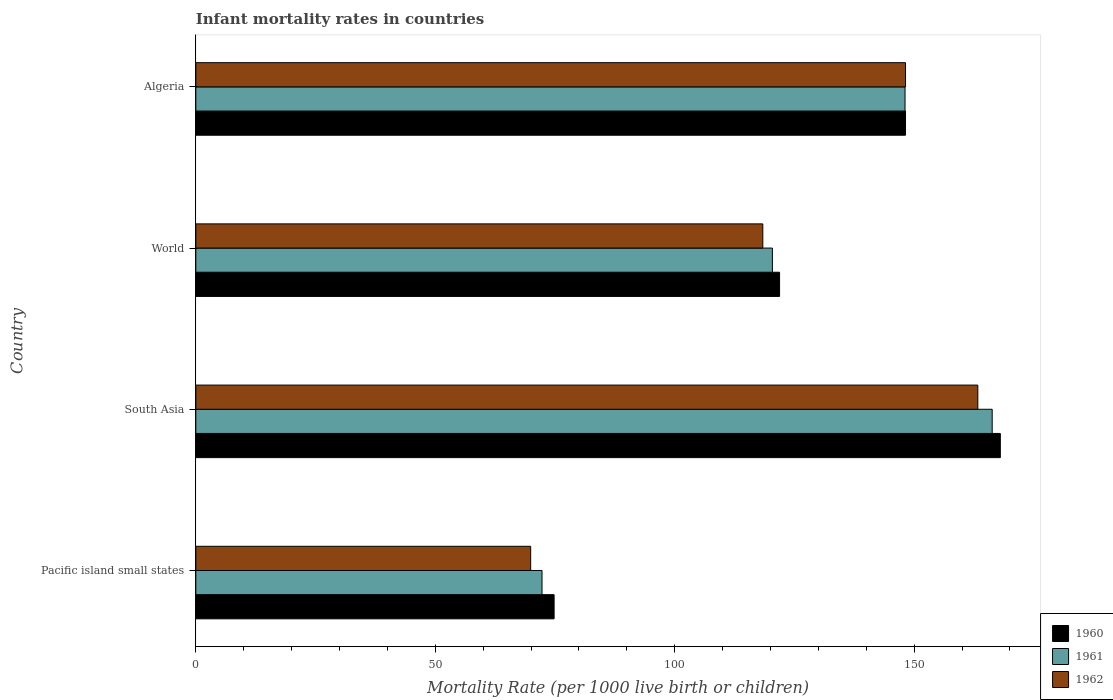How many bars are there on the 3rd tick from the top?
Provide a succinct answer. 3. What is the label of the 2nd group of bars from the top?
Make the answer very short. World. What is the infant mortality rate in 1962 in Pacific island small states?
Your answer should be compact. 69.93. Across all countries, what is the maximum infant mortality rate in 1960?
Keep it short and to the point. 168. Across all countries, what is the minimum infant mortality rate in 1962?
Make the answer very short. 69.93. In which country was the infant mortality rate in 1962 maximum?
Offer a very short reply. South Asia. In which country was the infant mortality rate in 1962 minimum?
Keep it short and to the point. Pacific island small states. What is the total infant mortality rate in 1961 in the graph?
Your answer should be very brief. 507.09. What is the difference between the infant mortality rate in 1960 in Algeria and that in World?
Provide a succinct answer. 26.3. What is the difference between the infant mortality rate in 1961 in Algeria and the infant mortality rate in 1960 in Pacific island small states?
Offer a very short reply. 73.28. What is the average infant mortality rate in 1961 per country?
Provide a short and direct response. 126.77. What is the difference between the infant mortality rate in 1960 and infant mortality rate in 1961 in Algeria?
Keep it short and to the point. 0.1. What is the ratio of the infant mortality rate in 1961 in Algeria to that in World?
Offer a terse response. 1.23. What is the difference between the highest and the second highest infant mortality rate in 1960?
Provide a short and direct response. 19.8. What is the difference between the highest and the lowest infant mortality rate in 1961?
Offer a very short reply. 94.01. In how many countries, is the infant mortality rate in 1961 greater than the average infant mortality rate in 1961 taken over all countries?
Your response must be concise. 2. Is the sum of the infant mortality rate in 1961 in Algeria and Pacific island small states greater than the maximum infant mortality rate in 1960 across all countries?
Keep it short and to the point. Yes. What does the 2nd bar from the top in Pacific island small states represents?
Make the answer very short. 1961. What does the 1st bar from the bottom in South Asia represents?
Keep it short and to the point. 1960. How many bars are there?
Provide a short and direct response. 12. Are all the bars in the graph horizontal?
Give a very brief answer. Yes. Are the values on the major ticks of X-axis written in scientific E-notation?
Your answer should be very brief. No. Does the graph contain any zero values?
Your answer should be very brief. No. How are the legend labels stacked?
Give a very brief answer. Vertical. What is the title of the graph?
Your answer should be compact. Infant mortality rates in countries. What is the label or title of the X-axis?
Ensure brevity in your answer.  Mortality Rate (per 1000 live birth or children). What is the label or title of the Y-axis?
Keep it short and to the point. Country. What is the Mortality Rate (per 1000 live birth or children) in 1960 in Pacific island small states?
Ensure brevity in your answer.  74.82. What is the Mortality Rate (per 1000 live birth or children) in 1961 in Pacific island small states?
Your response must be concise. 72.29. What is the Mortality Rate (per 1000 live birth or children) in 1962 in Pacific island small states?
Your response must be concise. 69.93. What is the Mortality Rate (per 1000 live birth or children) in 1960 in South Asia?
Ensure brevity in your answer.  168. What is the Mortality Rate (per 1000 live birth or children) of 1961 in South Asia?
Your response must be concise. 166.3. What is the Mortality Rate (per 1000 live birth or children) in 1962 in South Asia?
Offer a terse response. 163.3. What is the Mortality Rate (per 1000 live birth or children) of 1960 in World?
Offer a very short reply. 121.9. What is the Mortality Rate (per 1000 live birth or children) in 1961 in World?
Give a very brief answer. 120.4. What is the Mortality Rate (per 1000 live birth or children) of 1962 in World?
Provide a succinct answer. 118.4. What is the Mortality Rate (per 1000 live birth or children) of 1960 in Algeria?
Your answer should be very brief. 148.2. What is the Mortality Rate (per 1000 live birth or children) of 1961 in Algeria?
Offer a very short reply. 148.1. What is the Mortality Rate (per 1000 live birth or children) in 1962 in Algeria?
Make the answer very short. 148.2. Across all countries, what is the maximum Mortality Rate (per 1000 live birth or children) in 1960?
Provide a succinct answer. 168. Across all countries, what is the maximum Mortality Rate (per 1000 live birth or children) in 1961?
Your response must be concise. 166.3. Across all countries, what is the maximum Mortality Rate (per 1000 live birth or children) in 1962?
Offer a terse response. 163.3. Across all countries, what is the minimum Mortality Rate (per 1000 live birth or children) of 1960?
Ensure brevity in your answer.  74.82. Across all countries, what is the minimum Mortality Rate (per 1000 live birth or children) in 1961?
Keep it short and to the point. 72.29. Across all countries, what is the minimum Mortality Rate (per 1000 live birth or children) in 1962?
Your response must be concise. 69.93. What is the total Mortality Rate (per 1000 live birth or children) of 1960 in the graph?
Provide a succinct answer. 512.92. What is the total Mortality Rate (per 1000 live birth or children) in 1961 in the graph?
Your answer should be very brief. 507.09. What is the total Mortality Rate (per 1000 live birth or children) of 1962 in the graph?
Your answer should be very brief. 499.83. What is the difference between the Mortality Rate (per 1000 live birth or children) of 1960 in Pacific island small states and that in South Asia?
Give a very brief answer. -93.18. What is the difference between the Mortality Rate (per 1000 live birth or children) in 1961 in Pacific island small states and that in South Asia?
Provide a succinct answer. -94.01. What is the difference between the Mortality Rate (per 1000 live birth or children) of 1962 in Pacific island small states and that in South Asia?
Offer a terse response. -93.37. What is the difference between the Mortality Rate (per 1000 live birth or children) of 1960 in Pacific island small states and that in World?
Offer a terse response. -47.08. What is the difference between the Mortality Rate (per 1000 live birth or children) in 1961 in Pacific island small states and that in World?
Offer a terse response. -48.11. What is the difference between the Mortality Rate (per 1000 live birth or children) in 1962 in Pacific island small states and that in World?
Make the answer very short. -48.47. What is the difference between the Mortality Rate (per 1000 live birth or children) in 1960 in Pacific island small states and that in Algeria?
Your answer should be compact. -73.38. What is the difference between the Mortality Rate (per 1000 live birth or children) in 1961 in Pacific island small states and that in Algeria?
Offer a very short reply. -75.81. What is the difference between the Mortality Rate (per 1000 live birth or children) of 1962 in Pacific island small states and that in Algeria?
Provide a short and direct response. -78.27. What is the difference between the Mortality Rate (per 1000 live birth or children) of 1960 in South Asia and that in World?
Your answer should be very brief. 46.1. What is the difference between the Mortality Rate (per 1000 live birth or children) in 1961 in South Asia and that in World?
Provide a succinct answer. 45.9. What is the difference between the Mortality Rate (per 1000 live birth or children) of 1962 in South Asia and that in World?
Provide a short and direct response. 44.9. What is the difference between the Mortality Rate (per 1000 live birth or children) in 1960 in South Asia and that in Algeria?
Ensure brevity in your answer.  19.8. What is the difference between the Mortality Rate (per 1000 live birth or children) of 1960 in World and that in Algeria?
Your response must be concise. -26.3. What is the difference between the Mortality Rate (per 1000 live birth or children) of 1961 in World and that in Algeria?
Ensure brevity in your answer.  -27.7. What is the difference between the Mortality Rate (per 1000 live birth or children) of 1962 in World and that in Algeria?
Offer a terse response. -29.8. What is the difference between the Mortality Rate (per 1000 live birth or children) of 1960 in Pacific island small states and the Mortality Rate (per 1000 live birth or children) of 1961 in South Asia?
Keep it short and to the point. -91.48. What is the difference between the Mortality Rate (per 1000 live birth or children) in 1960 in Pacific island small states and the Mortality Rate (per 1000 live birth or children) in 1962 in South Asia?
Make the answer very short. -88.48. What is the difference between the Mortality Rate (per 1000 live birth or children) of 1961 in Pacific island small states and the Mortality Rate (per 1000 live birth or children) of 1962 in South Asia?
Keep it short and to the point. -91.01. What is the difference between the Mortality Rate (per 1000 live birth or children) in 1960 in Pacific island small states and the Mortality Rate (per 1000 live birth or children) in 1961 in World?
Your answer should be compact. -45.58. What is the difference between the Mortality Rate (per 1000 live birth or children) in 1960 in Pacific island small states and the Mortality Rate (per 1000 live birth or children) in 1962 in World?
Your answer should be compact. -43.58. What is the difference between the Mortality Rate (per 1000 live birth or children) of 1961 in Pacific island small states and the Mortality Rate (per 1000 live birth or children) of 1962 in World?
Provide a succinct answer. -46.11. What is the difference between the Mortality Rate (per 1000 live birth or children) of 1960 in Pacific island small states and the Mortality Rate (per 1000 live birth or children) of 1961 in Algeria?
Offer a very short reply. -73.28. What is the difference between the Mortality Rate (per 1000 live birth or children) in 1960 in Pacific island small states and the Mortality Rate (per 1000 live birth or children) in 1962 in Algeria?
Provide a short and direct response. -73.38. What is the difference between the Mortality Rate (per 1000 live birth or children) of 1961 in Pacific island small states and the Mortality Rate (per 1000 live birth or children) of 1962 in Algeria?
Keep it short and to the point. -75.91. What is the difference between the Mortality Rate (per 1000 live birth or children) of 1960 in South Asia and the Mortality Rate (per 1000 live birth or children) of 1961 in World?
Your answer should be compact. 47.6. What is the difference between the Mortality Rate (per 1000 live birth or children) in 1960 in South Asia and the Mortality Rate (per 1000 live birth or children) in 1962 in World?
Your answer should be very brief. 49.6. What is the difference between the Mortality Rate (per 1000 live birth or children) in 1961 in South Asia and the Mortality Rate (per 1000 live birth or children) in 1962 in World?
Your answer should be compact. 47.9. What is the difference between the Mortality Rate (per 1000 live birth or children) in 1960 in South Asia and the Mortality Rate (per 1000 live birth or children) in 1962 in Algeria?
Make the answer very short. 19.8. What is the difference between the Mortality Rate (per 1000 live birth or children) of 1961 in South Asia and the Mortality Rate (per 1000 live birth or children) of 1962 in Algeria?
Provide a short and direct response. 18.1. What is the difference between the Mortality Rate (per 1000 live birth or children) in 1960 in World and the Mortality Rate (per 1000 live birth or children) in 1961 in Algeria?
Ensure brevity in your answer.  -26.2. What is the difference between the Mortality Rate (per 1000 live birth or children) in 1960 in World and the Mortality Rate (per 1000 live birth or children) in 1962 in Algeria?
Ensure brevity in your answer.  -26.3. What is the difference between the Mortality Rate (per 1000 live birth or children) of 1961 in World and the Mortality Rate (per 1000 live birth or children) of 1962 in Algeria?
Your response must be concise. -27.8. What is the average Mortality Rate (per 1000 live birth or children) in 1960 per country?
Give a very brief answer. 128.23. What is the average Mortality Rate (per 1000 live birth or children) in 1961 per country?
Keep it short and to the point. 126.77. What is the average Mortality Rate (per 1000 live birth or children) in 1962 per country?
Your answer should be very brief. 124.96. What is the difference between the Mortality Rate (per 1000 live birth or children) of 1960 and Mortality Rate (per 1000 live birth or children) of 1961 in Pacific island small states?
Ensure brevity in your answer.  2.53. What is the difference between the Mortality Rate (per 1000 live birth or children) in 1960 and Mortality Rate (per 1000 live birth or children) in 1962 in Pacific island small states?
Provide a succinct answer. 4.89. What is the difference between the Mortality Rate (per 1000 live birth or children) of 1961 and Mortality Rate (per 1000 live birth or children) of 1962 in Pacific island small states?
Your answer should be very brief. 2.37. What is the difference between the Mortality Rate (per 1000 live birth or children) in 1960 and Mortality Rate (per 1000 live birth or children) in 1961 in Algeria?
Ensure brevity in your answer.  0.1. What is the difference between the Mortality Rate (per 1000 live birth or children) in 1960 and Mortality Rate (per 1000 live birth or children) in 1962 in Algeria?
Offer a very short reply. 0. What is the difference between the Mortality Rate (per 1000 live birth or children) of 1961 and Mortality Rate (per 1000 live birth or children) of 1962 in Algeria?
Provide a short and direct response. -0.1. What is the ratio of the Mortality Rate (per 1000 live birth or children) in 1960 in Pacific island small states to that in South Asia?
Make the answer very short. 0.45. What is the ratio of the Mortality Rate (per 1000 live birth or children) of 1961 in Pacific island small states to that in South Asia?
Give a very brief answer. 0.43. What is the ratio of the Mortality Rate (per 1000 live birth or children) of 1962 in Pacific island small states to that in South Asia?
Your response must be concise. 0.43. What is the ratio of the Mortality Rate (per 1000 live birth or children) of 1960 in Pacific island small states to that in World?
Give a very brief answer. 0.61. What is the ratio of the Mortality Rate (per 1000 live birth or children) of 1961 in Pacific island small states to that in World?
Keep it short and to the point. 0.6. What is the ratio of the Mortality Rate (per 1000 live birth or children) of 1962 in Pacific island small states to that in World?
Ensure brevity in your answer.  0.59. What is the ratio of the Mortality Rate (per 1000 live birth or children) in 1960 in Pacific island small states to that in Algeria?
Offer a very short reply. 0.5. What is the ratio of the Mortality Rate (per 1000 live birth or children) of 1961 in Pacific island small states to that in Algeria?
Your answer should be compact. 0.49. What is the ratio of the Mortality Rate (per 1000 live birth or children) of 1962 in Pacific island small states to that in Algeria?
Ensure brevity in your answer.  0.47. What is the ratio of the Mortality Rate (per 1000 live birth or children) in 1960 in South Asia to that in World?
Give a very brief answer. 1.38. What is the ratio of the Mortality Rate (per 1000 live birth or children) in 1961 in South Asia to that in World?
Give a very brief answer. 1.38. What is the ratio of the Mortality Rate (per 1000 live birth or children) of 1962 in South Asia to that in World?
Provide a succinct answer. 1.38. What is the ratio of the Mortality Rate (per 1000 live birth or children) in 1960 in South Asia to that in Algeria?
Ensure brevity in your answer.  1.13. What is the ratio of the Mortality Rate (per 1000 live birth or children) in 1961 in South Asia to that in Algeria?
Keep it short and to the point. 1.12. What is the ratio of the Mortality Rate (per 1000 live birth or children) of 1962 in South Asia to that in Algeria?
Make the answer very short. 1.1. What is the ratio of the Mortality Rate (per 1000 live birth or children) of 1960 in World to that in Algeria?
Offer a terse response. 0.82. What is the ratio of the Mortality Rate (per 1000 live birth or children) of 1961 in World to that in Algeria?
Offer a very short reply. 0.81. What is the ratio of the Mortality Rate (per 1000 live birth or children) in 1962 in World to that in Algeria?
Your answer should be very brief. 0.8. What is the difference between the highest and the second highest Mortality Rate (per 1000 live birth or children) in 1960?
Your answer should be compact. 19.8. What is the difference between the highest and the second highest Mortality Rate (per 1000 live birth or children) of 1962?
Provide a succinct answer. 15.1. What is the difference between the highest and the lowest Mortality Rate (per 1000 live birth or children) of 1960?
Your answer should be compact. 93.18. What is the difference between the highest and the lowest Mortality Rate (per 1000 live birth or children) of 1961?
Your response must be concise. 94.01. What is the difference between the highest and the lowest Mortality Rate (per 1000 live birth or children) in 1962?
Offer a terse response. 93.37. 